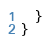<code> <loc_0><loc_0><loc_500><loc_500><_JavaScript_>  }
}
</code> 